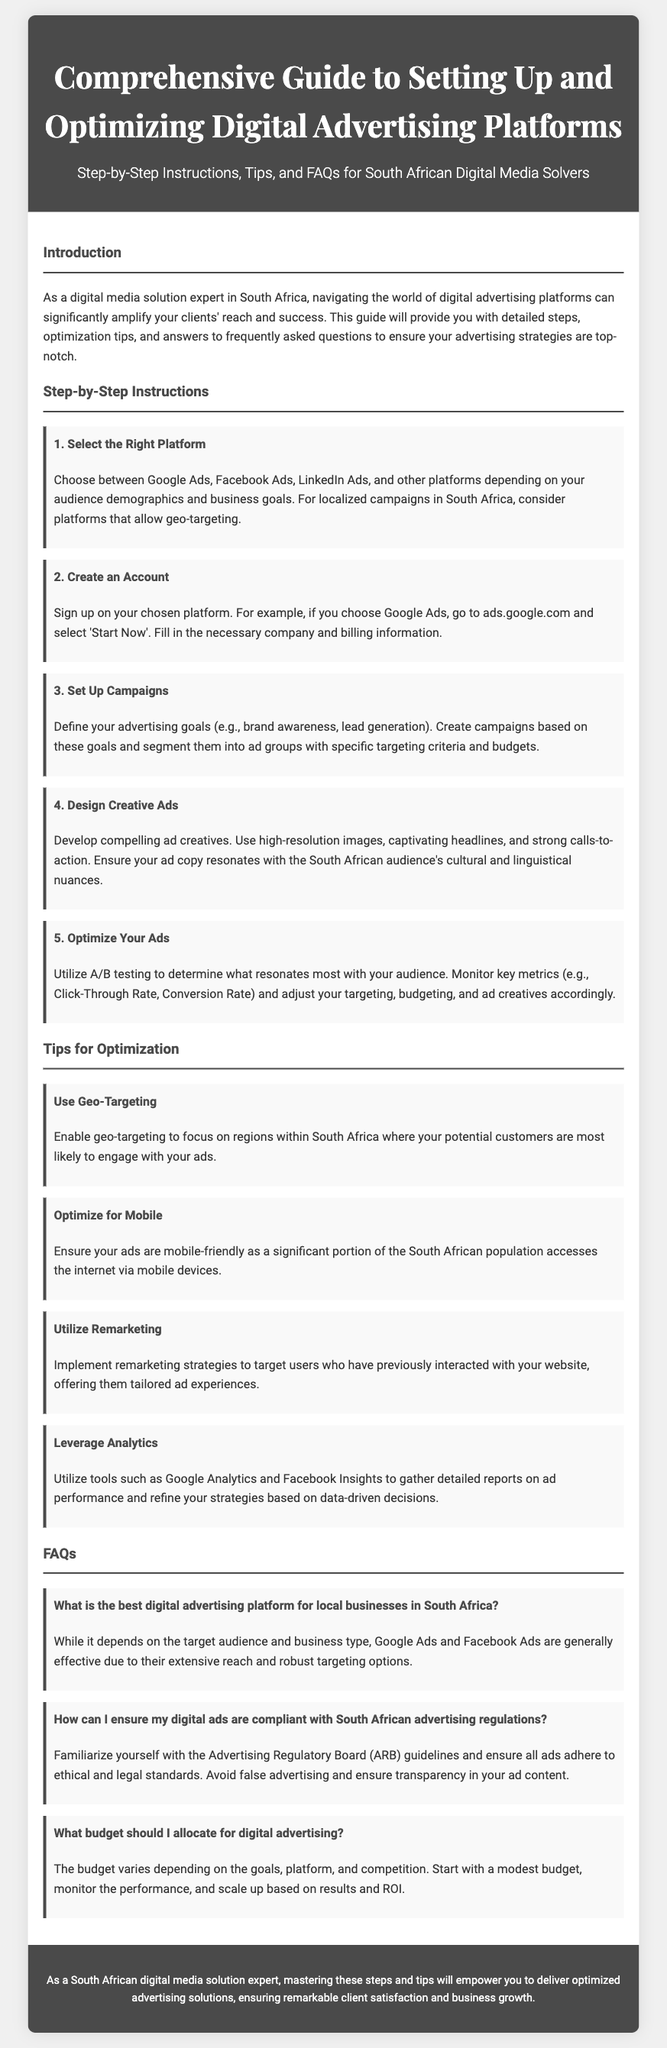What is the title of the document? The title, found in the header section of the document, states the focus of the guide.
Answer: Comprehensive Guide to Setting Up and Optimizing Digital Advertising Platforms What is the first step in the instructions? The first step is outlined in the "Step-by-Step Instructions" section, specifically about selecting a platform.
Answer: Select the Right Platform What are two platforms mentioned for digital advertising? The document lists specific platforms as options for advertising strategies in the first step.
Answer: Google Ads, Facebook Ads What should you do to optimize your ads? The document emphasizes the use of a specific method to improve advertisement outcomes, reflecting best practices.
Answer: Utilize A/B testing How can you ensure your ads comply with regulations? This question pertains to the FAQs section, specifically addressing compliance with advertising laws.
Answer: Familiarize yourself with the Advertising Regulatory Board guidelines What percentage of the population accesses the internet via mobile devices? The document suggests a significant portion, which implies a substantial focus in one of the tips for optimization.
Answer: Significant portion (implied) What is the budget recommendation? The FAQ section provides guidance on how to approach budgeting for digital advertising campaigns.
Answer: Start with a modest budget What does the footer suggest about mastering these steps? The footer summarizes the benefits of following the guide, indicating the potential outcomes for practitioners in the field.
Answer: Deliver optimized advertising solutions How many tips for optimization are provided? The tips section enumerates the strategies, which indicates a specific number of recommendations.
Answer: Four tips 